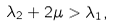<formula> <loc_0><loc_0><loc_500><loc_500>\lambda _ { 2 } + 2 \mu > \lambda _ { 1 } ,</formula> 